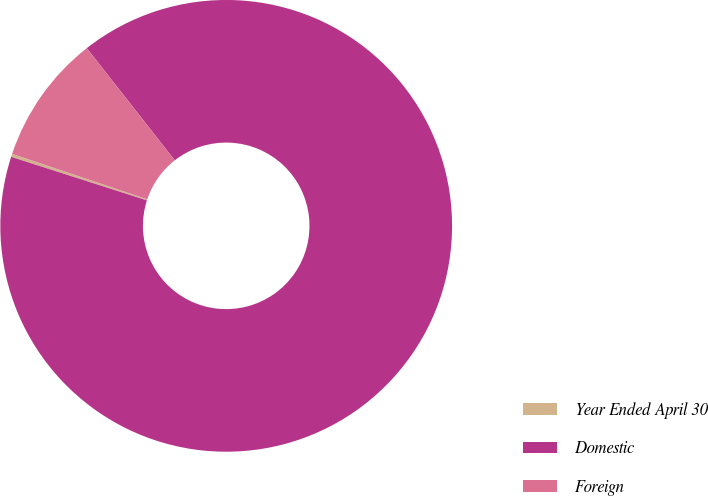Convert chart to OTSL. <chart><loc_0><loc_0><loc_500><loc_500><pie_chart><fcel>Year Ended April 30<fcel>Domestic<fcel>Foreign<nl><fcel>0.22%<fcel>90.52%<fcel>9.25%<nl></chart> 